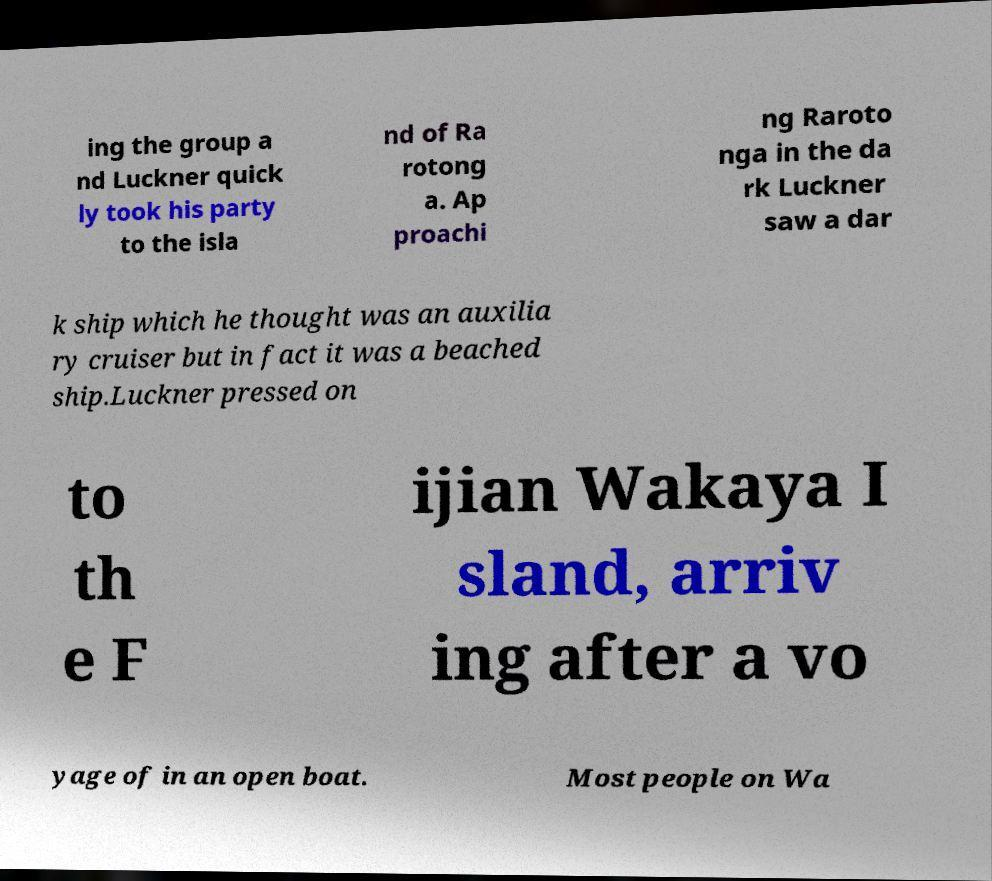Can you accurately transcribe the text from the provided image for me? ing the group a nd Luckner quick ly took his party to the isla nd of Ra rotong a. Ap proachi ng Raroto nga in the da rk Luckner saw a dar k ship which he thought was an auxilia ry cruiser but in fact it was a beached ship.Luckner pressed on to th e F ijian Wakaya I sland, arriv ing after a vo yage of in an open boat. Most people on Wa 